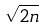<formula> <loc_0><loc_0><loc_500><loc_500>\sqrt { 2 n }</formula> 